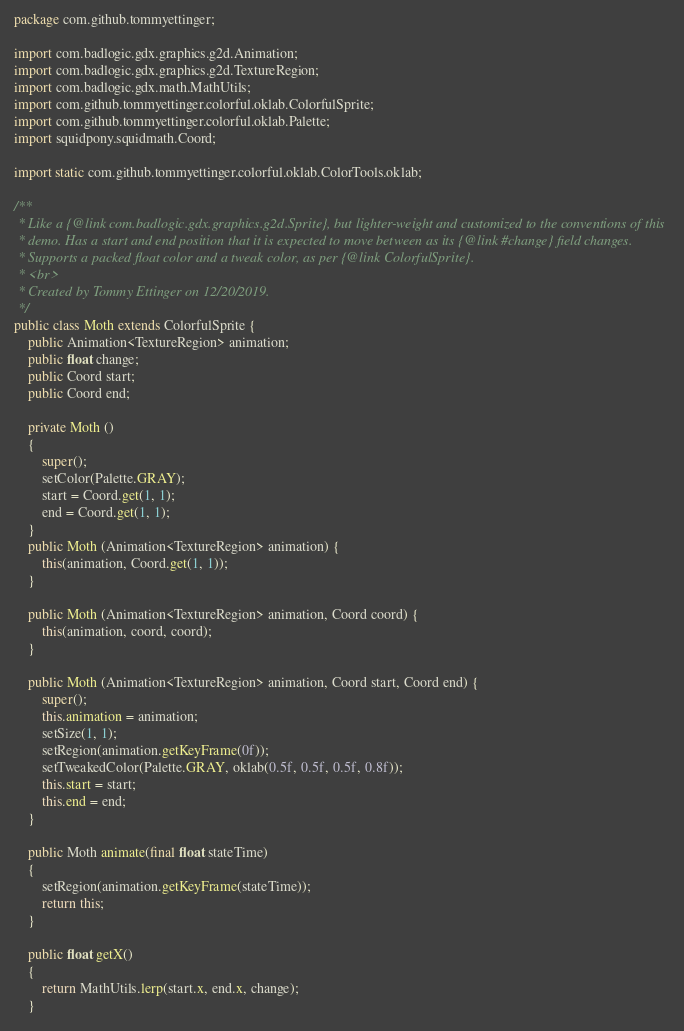<code> <loc_0><loc_0><loc_500><loc_500><_Java_>package com.github.tommyettinger;

import com.badlogic.gdx.graphics.g2d.Animation;
import com.badlogic.gdx.graphics.g2d.TextureRegion;
import com.badlogic.gdx.math.MathUtils;
import com.github.tommyettinger.colorful.oklab.ColorfulSprite;
import com.github.tommyettinger.colorful.oklab.Palette;
import squidpony.squidmath.Coord;

import static com.github.tommyettinger.colorful.oklab.ColorTools.oklab;

/**
 * Like a {@link com.badlogic.gdx.graphics.g2d.Sprite}, but lighter-weight and customized to the conventions of this
 * demo. Has a start and end position that it is expected to move between as its {@link #change} field changes.
 * Supports a packed float color and a tweak color, as per {@link ColorfulSprite}.
 * <br>
 * Created by Tommy Ettinger on 12/20/2019.
 */
public class Moth extends ColorfulSprite {
    public Animation<TextureRegion> animation;
    public float change;
    public Coord start;
    public Coord end;

    private Moth ()
    {
        super();
        setColor(Palette.GRAY);
        start = Coord.get(1, 1);
        end = Coord.get(1, 1);
    }
    public Moth (Animation<TextureRegion> animation) {
        this(animation, Coord.get(1, 1));
    }

    public Moth (Animation<TextureRegion> animation, Coord coord) {
        this(animation, coord, coord);
    }

    public Moth (Animation<TextureRegion> animation, Coord start, Coord end) {
        super();
        this.animation = animation;
        setSize(1, 1);
        setRegion(animation.getKeyFrame(0f));
        setTweakedColor(Palette.GRAY, oklab(0.5f, 0.5f, 0.5f, 0.8f));
        this.start = start;
        this.end = end;
    }

    public Moth animate(final float stateTime)
    {
        setRegion(animation.getKeyFrame(stateTime));
        return this;
    }
    
    public float getX()
    {
        return MathUtils.lerp(start.x, end.x, change);
    }
</code> 